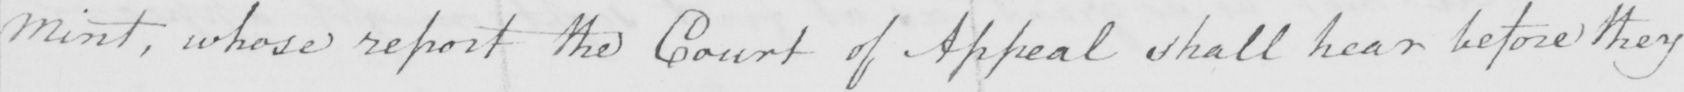What is written in this line of handwriting? Mint , whose report the Court of Appeal shall hear before they 